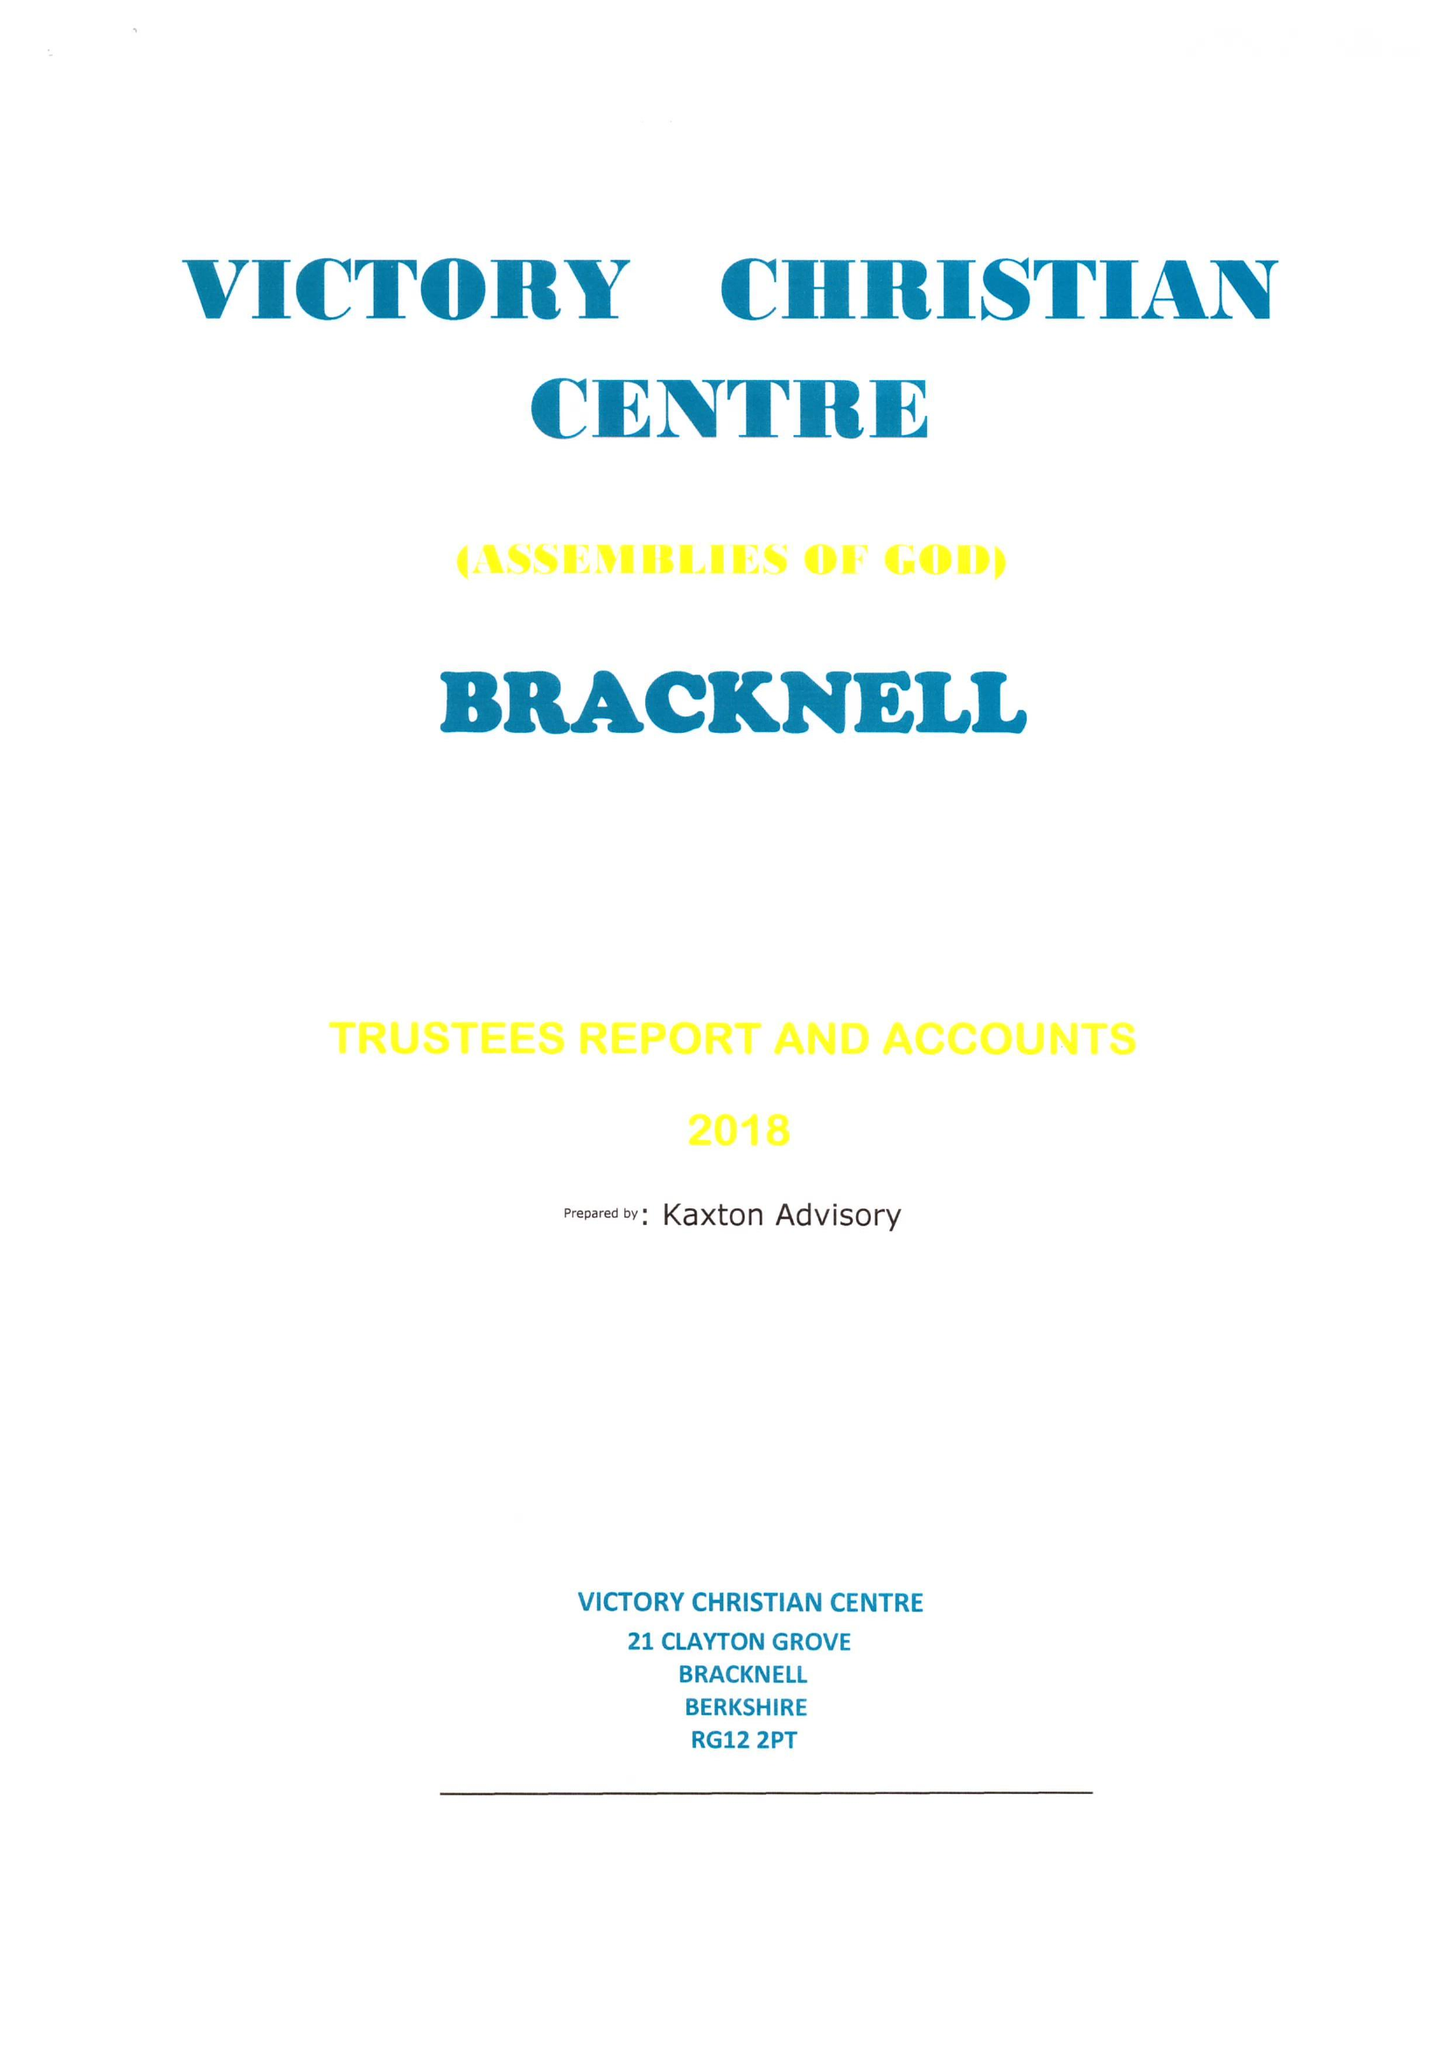What is the value for the address__postcode?
Answer the question using a single word or phrase. RG12 2PT 